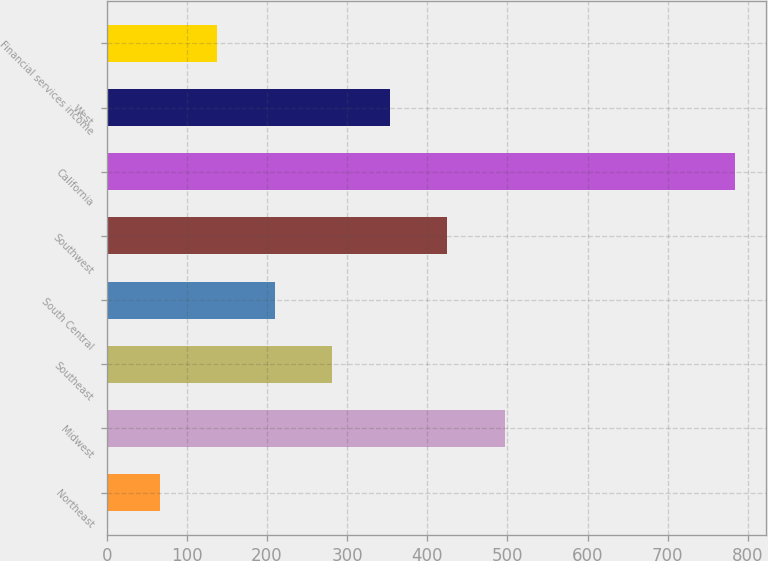Convert chart. <chart><loc_0><loc_0><loc_500><loc_500><bar_chart><fcel>Northeast<fcel>Midwest<fcel>Southeast<fcel>South Central<fcel>Southwest<fcel>California<fcel>West<fcel>Financial services income<nl><fcel>66.1<fcel>496.9<fcel>281.5<fcel>209.7<fcel>425.1<fcel>784.1<fcel>353.3<fcel>137.9<nl></chart> 